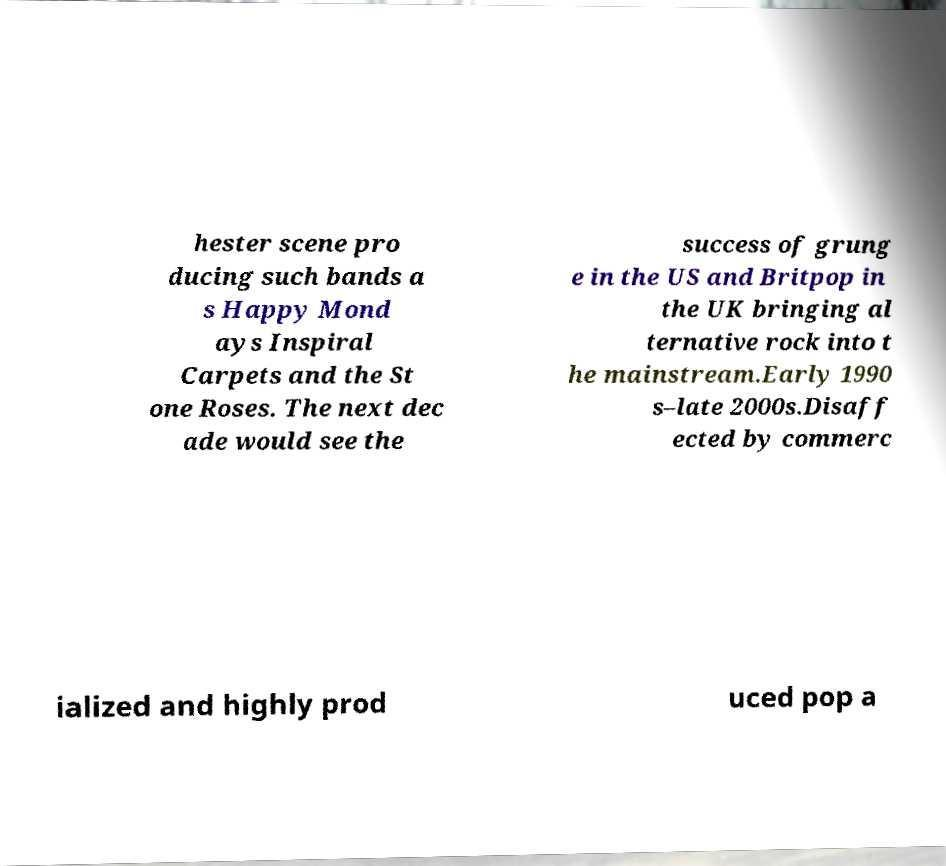Can you read and provide the text displayed in the image?This photo seems to have some interesting text. Can you extract and type it out for me? hester scene pro ducing such bands a s Happy Mond ays Inspiral Carpets and the St one Roses. The next dec ade would see the success of grung e in the US and Britpop in the UK bringing al ternative rock into t he mainstream.Early 1990 s–late 2000s.Disaff ected by commerc ialized and highly prod uced pop a 